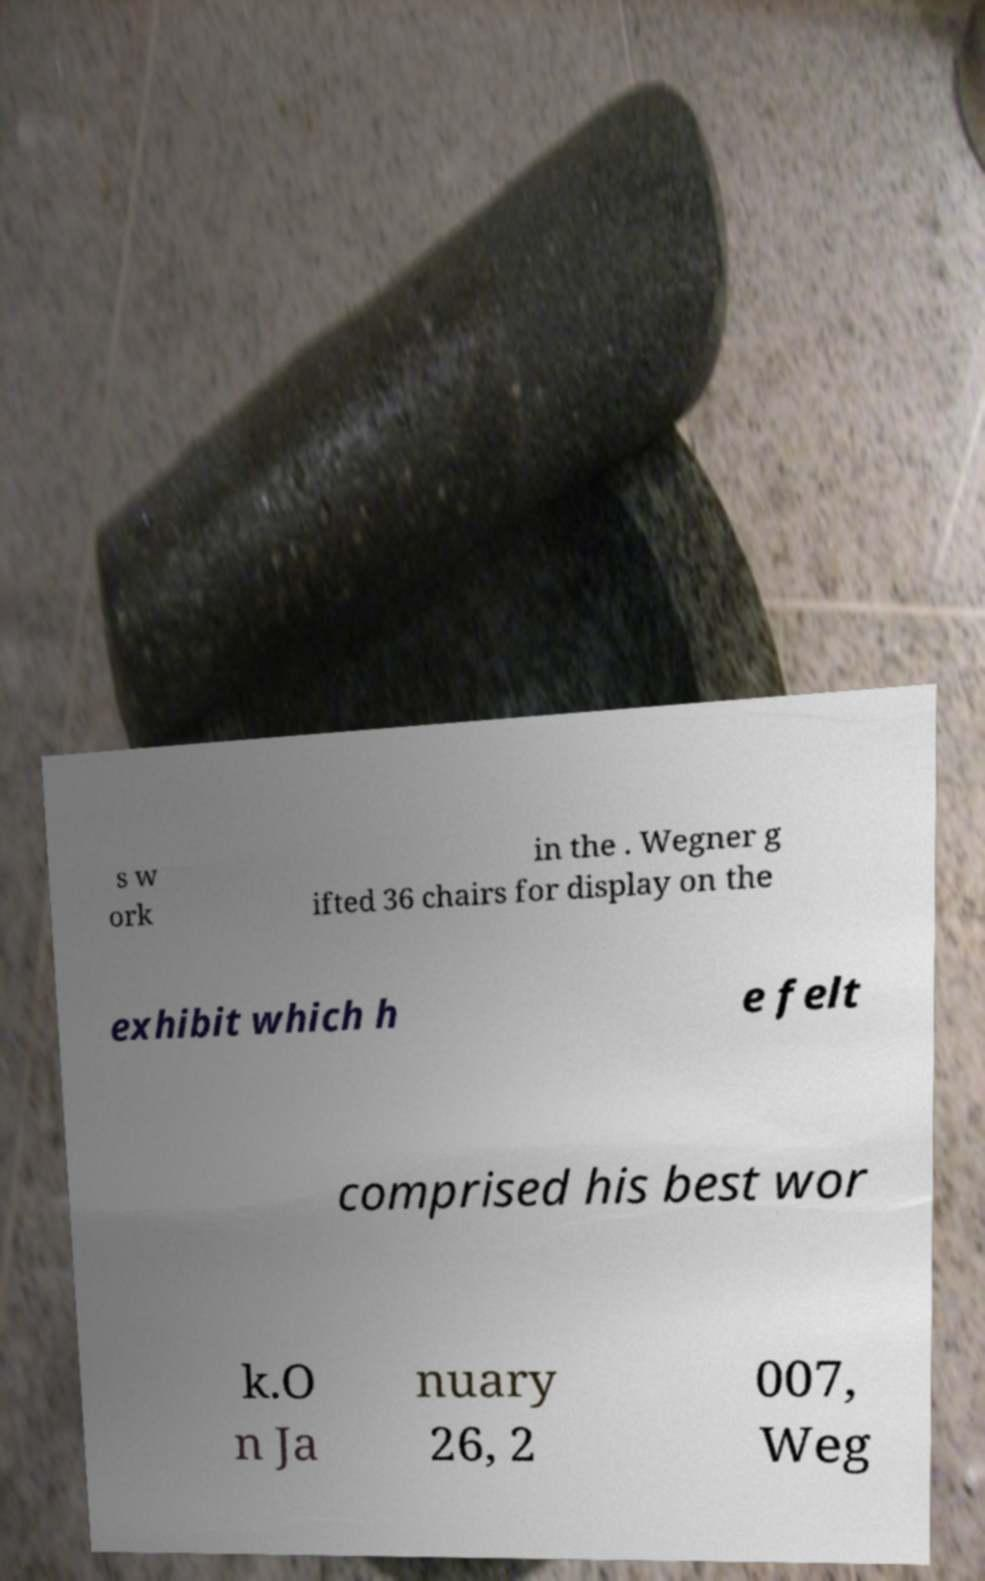Could you extract and type out the text from this image? s w ork in the . Wegner g ifted 36 chairs for display on the exhibit which h e felt comprised his best wor k.O n Ja nuary 26, 2 007, Weg 